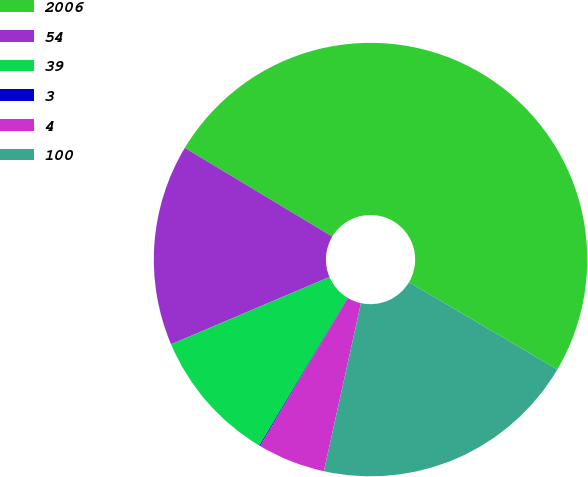<chart> <loc_0><loc_0><loc_500><loc_500><pie_chart><fcel>2006<fcel>54<fcel>39<fcel>3<fcel>4<fcel>100<nl><fcel>49.85%<fcel>15.01%<fcel>10.03%<fcel>0.07%<fcel>5.05%<fcel>19.99%<nl></chart> 